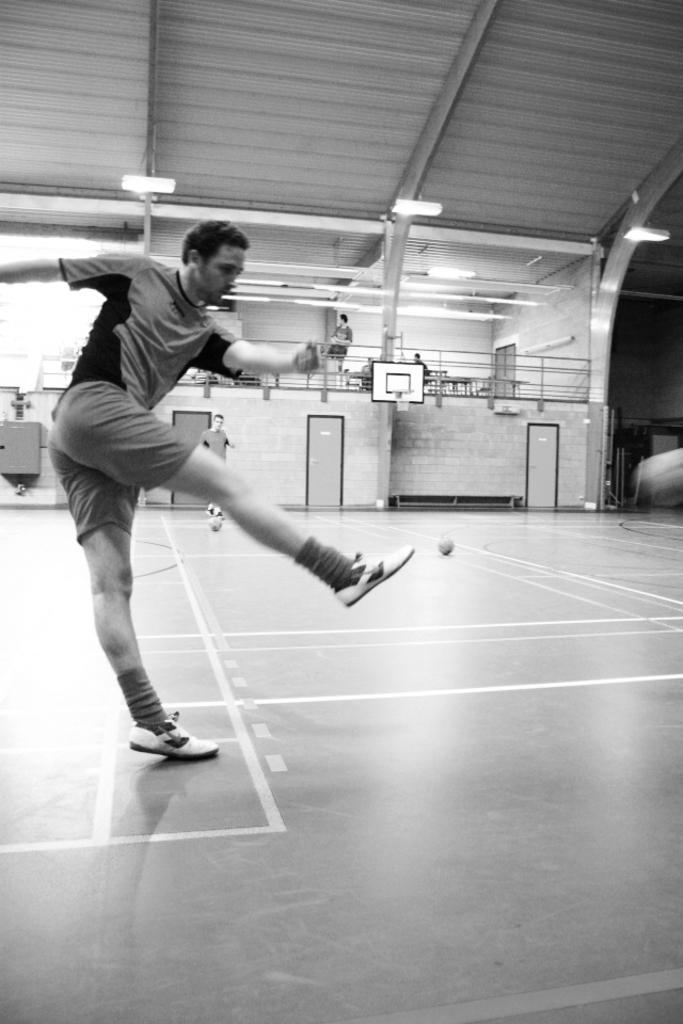Describe this image in one or two sentences. In this picture there is a man who is wearing t-shirt, short and shoes. He is standing on the basketball court. In the back there is a man who is standing near to the basketball. In the background I can see the basketball court, net, doors, walls and other objects. On the tight I can see the shed. On the right I can see some lights which are placed on this steel pillar. 